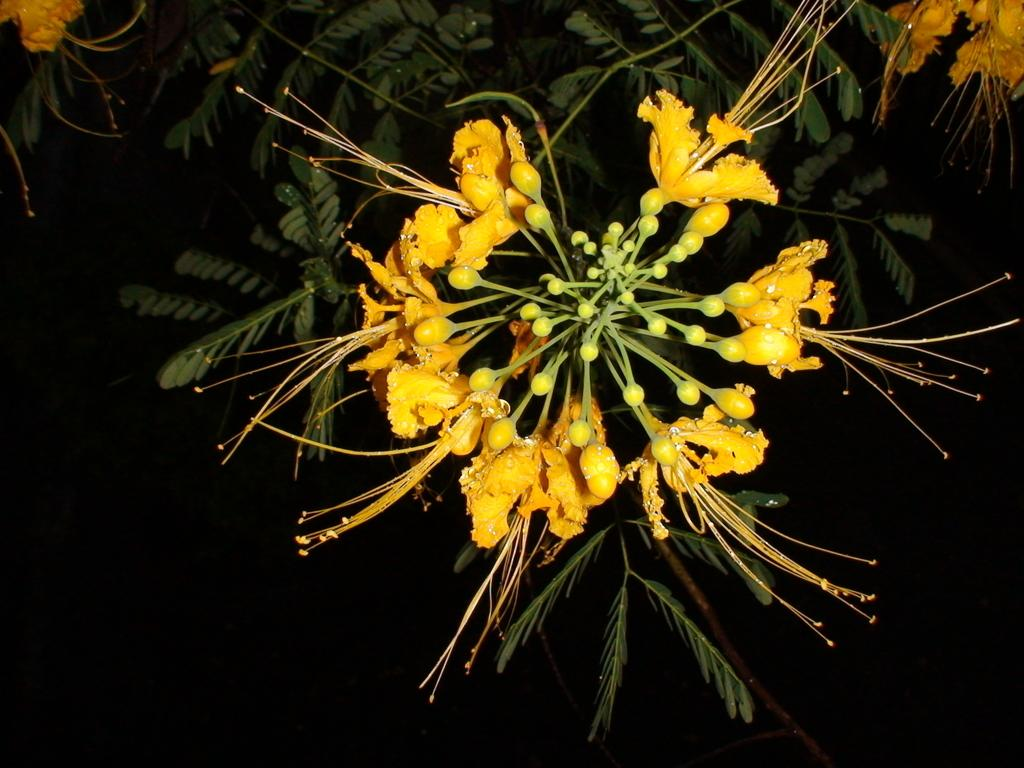What is the main subject of the image? The main subject of the image is flowers and buds in the center. Are there any other plant elements visible in the image? Yes, there are leaves, stems, and flowers of a tree at the top of the image. What is the color of the background in the image? The background of the image is dark. How many mice can be seen climbing on the flowers in the image? There are no mice present in the image; it features only flowers, buds, leaves, and stems. What type of beef is being served at the event in the image? There is no event or beef present in the image; it focuses solely on plant elements. 